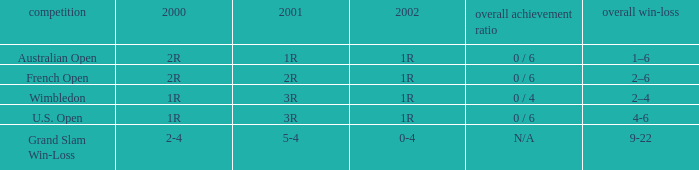Which career win-loss record has a 1r in 2002, a 2r in 2000 and a 2r in 2001? 2–6. 